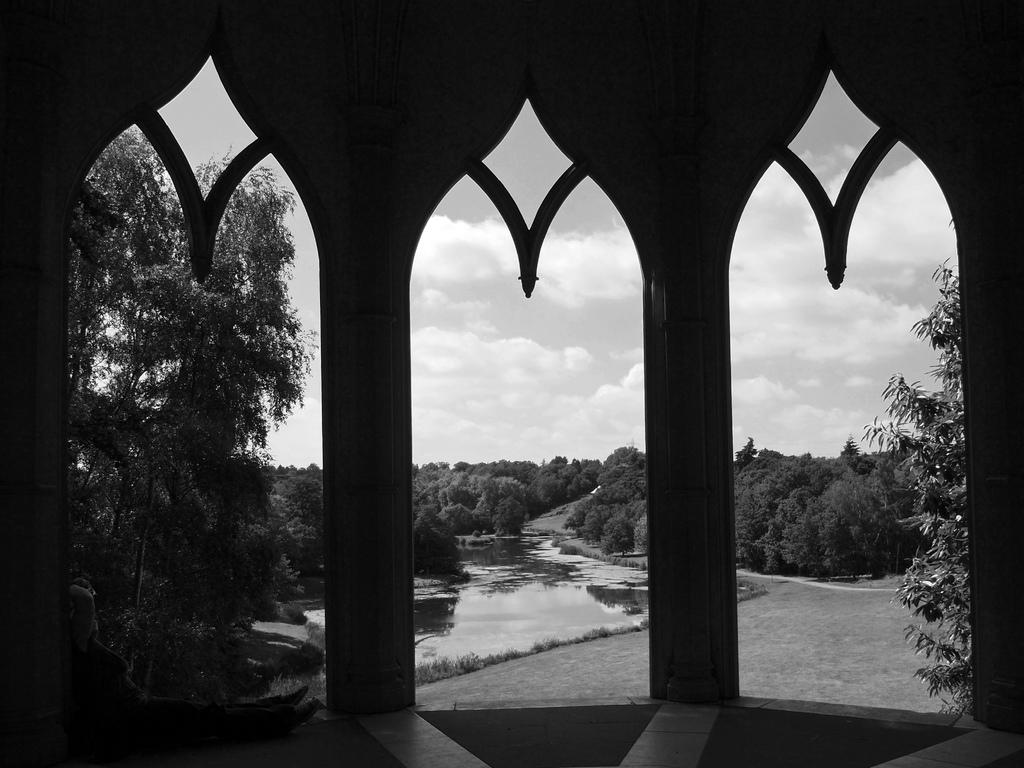What structure is present in the image? There is a shed in the image. What can be seen through the shed? Trees and water are visible through the shed. What is visible in the sky in the image? Clouds are visible in the sky. What part of the sky is visible in the image? The sky is visible in the image. Can you see a basketball being played on the roof of the shed in the image? There is no basketball or roof visible in the image; it only shows a shed with trees and water visible through it. 